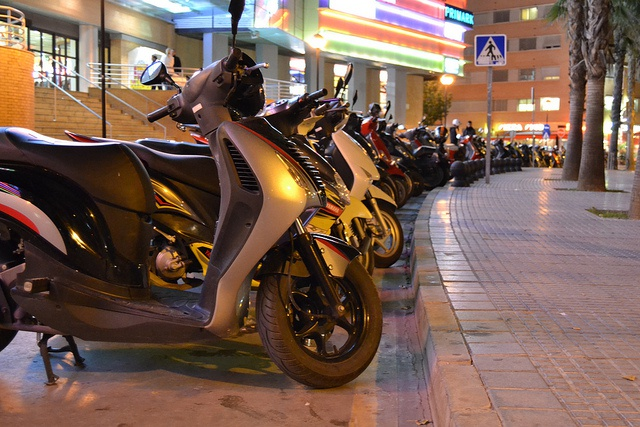Describe the objects in this image and their specific colors. I can see motorcycle in gray, black, maroon, and brown tones, motorcycle in gray, black, maroon, olive, and orange tones, motorcycle in gray, black, tan, olive, and maroon tones, motorcycle in gray, black, orange, maroon, and olive tones, and motorcycle in gray, black, maroon, and darkgray tones in this image. 